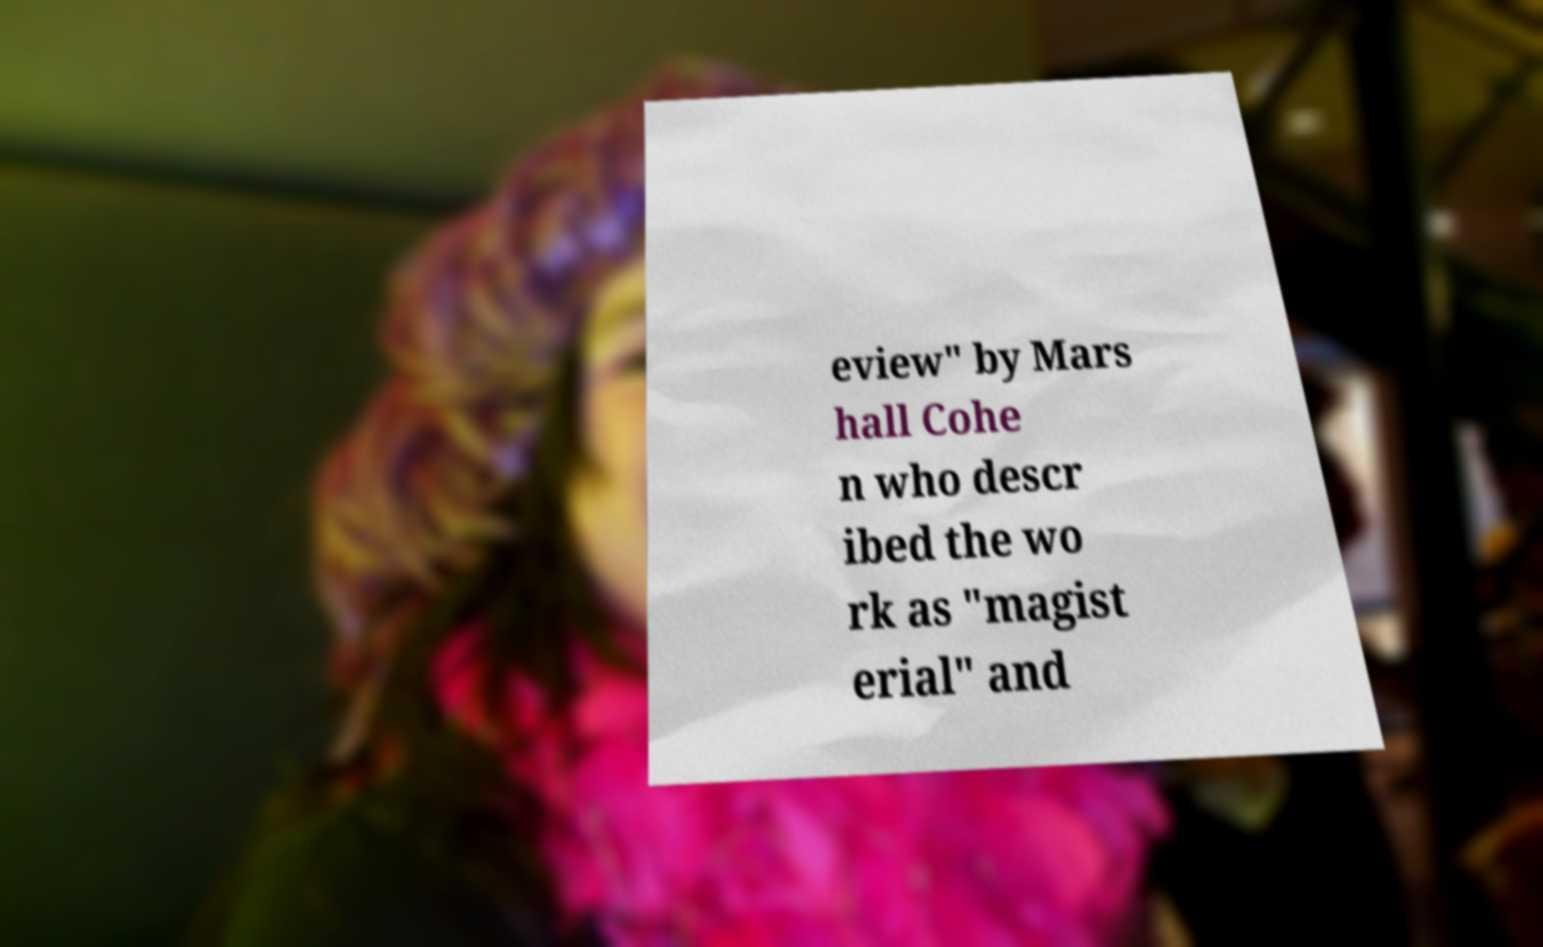I need the written content from this picture converted into text. Can you do that? eview" by Mars hall Cohe n who descr ibed the wo rk as "magist erial" and 